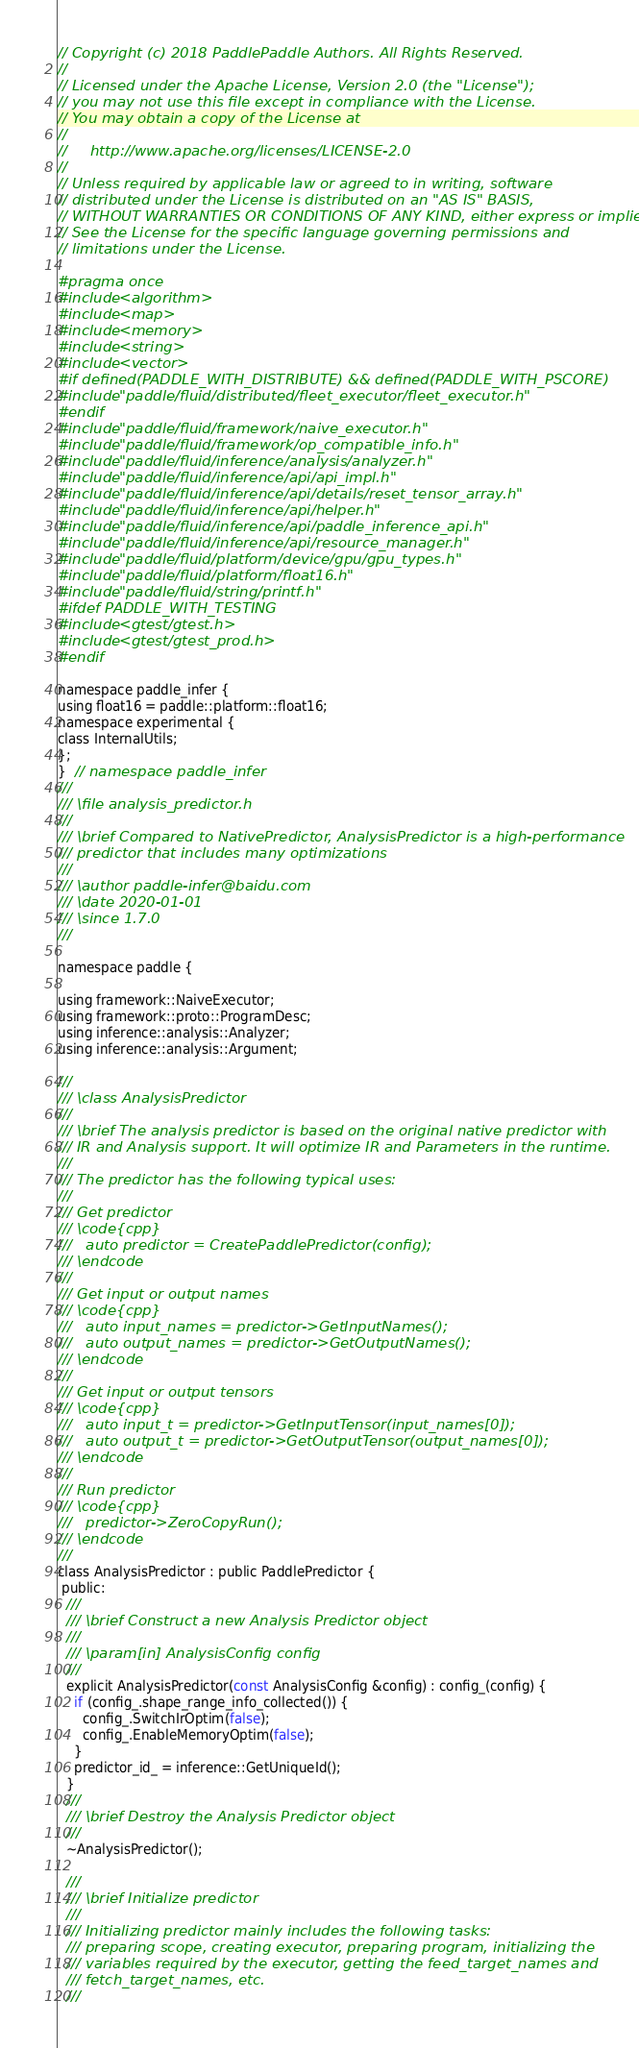<code> <loc_0><loc_0><loc_500><loc_500><_C_>// Copyright (c) 2018 PaddlePaddle Authors. All Rights Reserved.
//
// Licensed under the Apache License, Version 2.0 (the "License");
// you may not use this file except in compliance with the License.
// You may obtain a copy of the License at
//
//     http://www.apache.org/licenses/LICENSE-2.0
//
// Unless required by applicable law or agreed to in writing, software
// distributed under the License is distributed on an "AS IS" BASIS,
// WITHOUT WARRANTIES OR CONDITIONS OF ANY KIND, either express or implied.
// See the License for the specific language governing permissions and
// limitations under the License.

#pragma once
#include <algorithm>
#include <map>
#include <memory>
#include <string>
#include <vector>
#if defined(PADDLE_WITH_DISTRIBUTE) && defined(PADDLE_WITH_PSCORE)
#include "paddle/fluid/distributed/fleet_executor/fleet_executor.h"
#endif
#include "paddle/fluid/framework/naive_executor.h"
#include "paddle/fluid/framework/op_compatible_info.h"
#include "paddle/fluid/inference/analysis/analyzer.h"
#include "paddle/fluid/inference/api/api_impl.h"
#include "paddle/fluid/inference/api/details/reset_tensor_array.h"
#include "paddle/fluid/inference/api/helper.h"
#include "paddle/fluid/inference/api/paddle_inference_api.h"
#include "paddle/fluid/inference/api/resource_manager.h"
#include "paddle/fluid/platform/device/gpu/gpu_types.h"
#include "paddle/fluid/platform/float16.h"
#include "paddle/fluid/string/printf.h"
#ifdef PADDLE_WITH_TESTING
#include <gtest/gtest.h>
#include <gtest/gtest_prod.h>
#endif

namespace paddle_infer {
using float16 = paddle::platform::float16;
namespace experimental {
class InternalUtils;
};
}  // namespace paddle_infer
///
/// \file analysis_predictor.h
///
/// \brief Compared to NativePredictor, AnalysisPredictor is a high-performance
/// predictor that includes many optimizations
///
/// \author paddle-infer@baidu.com
/// \date 2020-01-01
/// \since 1.7.0
///

namespace paddle {

using framework::NaiveExecutor;
using framework::proto::ProgramDesc;
using inference::analysis::Analyzer;
using inference::analysis::Argument;

///
/// \class AnalysisPredictor
///
/// \brief The analysis predictor is based on the original native predictor with
/// IR and Analysis support. It will optimize IR and Parameters in the runtime.
///
/// The predictor has the following typical uses:
///
/// Get predictor
/// \code{cpp}
///   auto predictor = CreatePaddlePredictor(config);
/// \endcode
///
/// Get input or output names
/// \code{cpp}
///   auto input_names = predictor->GetInputNames();
///   auto output_names = predictor->GetOutputNames();
/// \endcode
///
/// Get input or output tensors
/// \code{cpp}
///   auto input_t = predictor->GetInputTensor(input_names[0]);
///   auto output_t = predictor->GetOutputTensor(output_names[0]);
/// \endcode
///
/// Run predictor
/// \code{cpp}
///   predictor->ZeroCopyRun();
/// \endcode
///
class AnalysisPredictor : public PaddlePredictor {
 public:
  ///
  /// \brief Construct a new Analysis Predictor object
  ///
  /// \param[in] AnalysisConfig config
  ///
  explicit AnalysisPredictor(const AnalysisConfig &config) : config_(config) {
    if (config_.shape_range_info_collected()) {
      config_.SwitchIrOptim(false);
      config_.EnableMemoryOptim(false);
    }
    predictor_id_ = inference::GetUniqueId();
  }
  ///
  /// \brief Destroy the Analysis Predictor object
  ///
  ~AnalysisPredictor();

  ///
  /// \brief Initialize predictor
  ///
  /// Initializing predictor mainly includes the following tasks:
  /// preparing scope, creating executor, preparing program, initializing the
  /// variables required by the executor, getting the feed_target_names and
  /// fetch_target_names, etc.
  ///</code> 